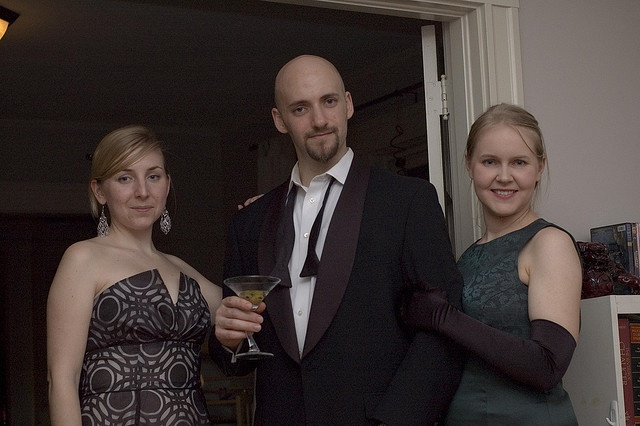Describe the objects in this image and their specific colors. I can see people in black, darkgray, and gray tones, people in black and gray tones, people in black and gray tones, wine glass in black, gray, and maroon tones, and tie in black, gray, and darkgray tones in this image. 